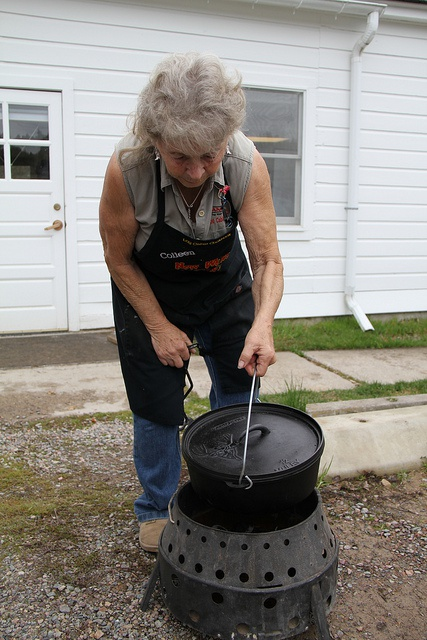Describe the objects in this image and their specific colors. I can see people in darkgray, black, gray, and maroon tones in this image. 